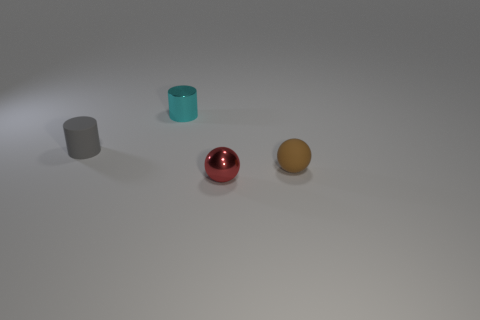Add 2 tiny red spheres. How many objects exist? 6 Add 2 cyan cylinders. How many cyan cylinders are left? 3 Add 4 tiny cyan objects. How many tiny cyan objects exist? 5 Subtract 0 yellow spheres. How many objects are left? 4 Subtract all small cyan metallic objects. Subtract all small balls. How many objects are left? 1 